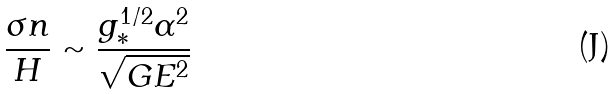<formula> <loc_0><loc_0><loc_500><loc_500>\frac { \sigma n } { H } \sim \frac { g _ { * } ^ { 1 / 2 } \alpha ^ { 2 } } { \sqrt { G E ^ { 2 } } }</formula> 